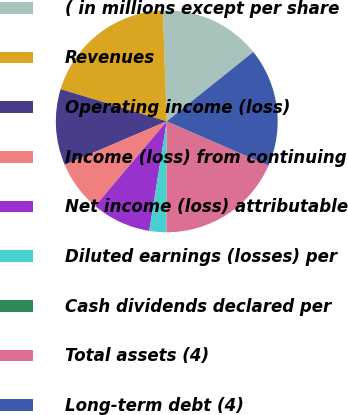Convert chart to OTSL. <chart><loc_0><loc_0><loc_500><loc_500><pie_chart><fcel>( in millions except per share<fcel>Revenues<fcel>Operating income (loss)<fcel>Income (loss) from continuing<fcel>Net income (loss) attributable<fcel>Diluted earnings (losses) per<fcel>Cash dividends declared per<fcel>Total assets (4)<fcel>Long-term debt (4)<nl><fcel>14.81%<fcel>19.75%<fcel>11.11%<fcel>7.41%<fcel>8.64%<fcel>2.47%<fcel>0.0%<fcel>18.52%<fcel>17.28%<nl></chart> 